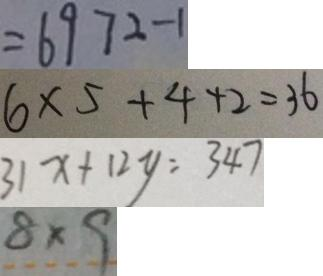<formula> <loc_0><loc_0><loc_500><loc_500>= 6 9 7 2 - 1 
 6 \times 5 + 4 + 2 = 3 6 
 3 1 x + 1 2 y = 3 4 7 
 8 \times 9</formula> 